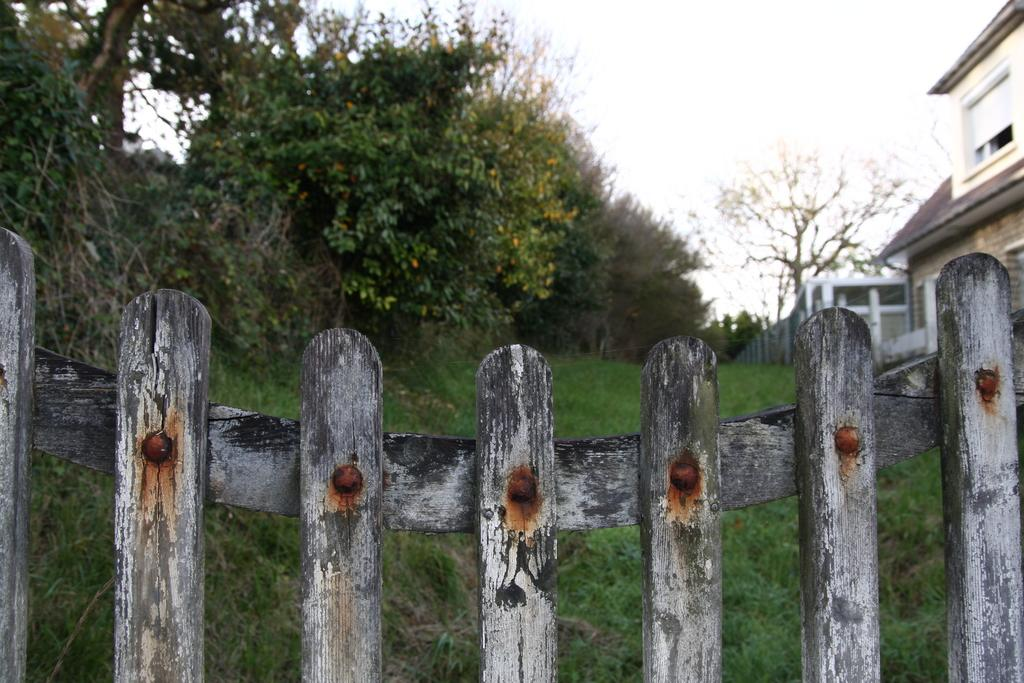What type of barrier is present in the image? There is a wooden fence in the image. What type of vegetation is visible in the image? There are trees in the image. What type of ground cover is present in the image? There is grass in the image. What type of structure is visible in the image? There is a building in the image. What part of the natural environment is visible in the image? The sky is visible in the image. Can you see any monkeys climbing the wooden fence in the image? There are no monkeys present in the image. Are there any tomatoes growing on the trees in the image? There are no tomatoes present in the image; the trees are not specified as fruit-bearing trees. 